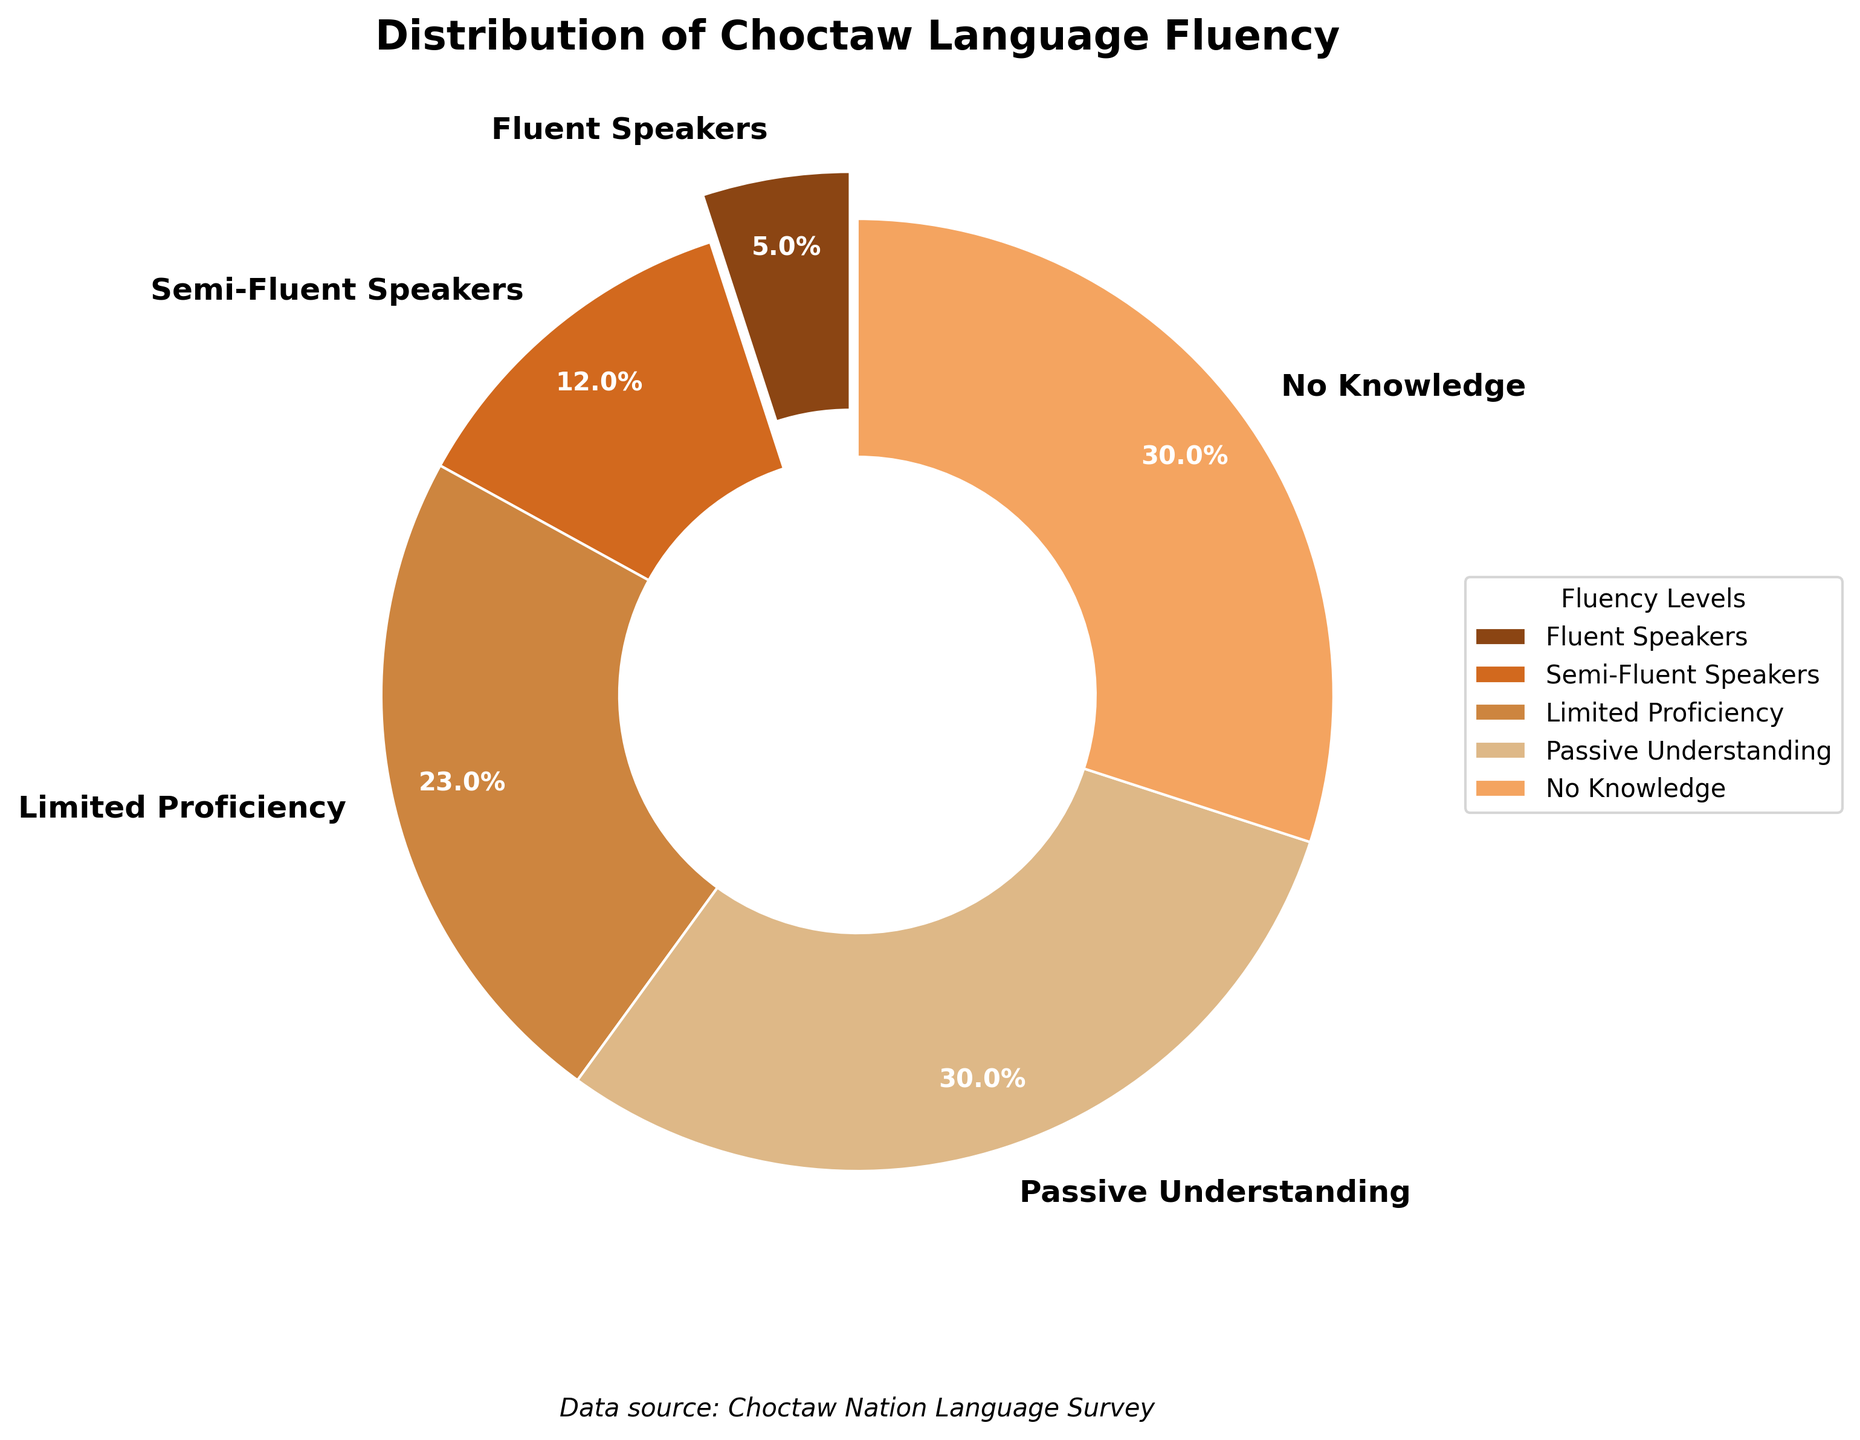What is the percentage of tribal members who are fluent speakers of the Choctaw language? The pie chart shows that the portion labeled "Fluent Speakers" has a percentage of 5% in the pie chart.
Answer: 5% Which fluency level has the highest percentage? By examining the sizes of the pie chart sections, the segments labeled "Passive Understanding" and "No Knowledge" each occupy the largest portion, both at 30%.
Answer: Passive Understanding and No Knowledge How many times more tribal members have passive understanding compared to those who are fluent speakers? The percentage of tribal members with passive understanding is 30%, and the percentage of fluent speakers is 5%. Dividing 30 by 5 gives the factor by which there are more members with passive understanding: 30 / 5 = 6.
Answer: 6 times What is the combined percentage of tribal members with limited proficiency and semi-fluent speakers? Adding the percentages of tribal members with limited proficiency (23%) and semi-fluent speakers (12%), we get 23 + 12 = 35%.
Answer: 35% Which fluency level has a greater percentage, Limited Proficiency or Semi-Fluent Speakers? By comparing the two sections, we see that Limited Proficiency (23%) is larger than Semi-Fluent Speakers (12%).
Answer: Limited Proficiency What percentage of tribal members have either no knowledge or passive understanding of the Choctaw language? Adding the percentages of tribal members with no knowledge (30%) and those with passive understanding (30%), we get 30 + 30 = 60%.
Answer: 60% What is the total percentage of tribal members who have some degree of proficiency (fluent, semi-fluent, limited proficiency) in the Choctaw language? Adding the percentages of fluent speakers (5%), semi-fluent speakers (12%), and those with limited proficiency (23%), we get 5 + 12 + 23 = 40%.
Answer: 40% Which section of the pie chart is visually the most prominent, and how can you tell? The most prominent section of the pie chart is one of the sections at 30% (either "Passive Understanding" or "No Knowledge") as they cover the largest areas of the chart.
Answer: Passive Understanding and No Knowledge (both at 30%) What is the difference in percentage between tribal members with fluent speakers and those with semi-fluent speakers? Subtracting the percentage of fluent speakers (5%) from that of semi-fluent speakers (12%), we get 12 - 5 = 7%.
Answer: 7% Is there an equal representation between the groups who have no knowledge and those who have passive understanding of the Choctaw language? Yes, both "No Knowledge" and "Passive Understanding" sections are labeled with 30%, indicating equal representation.
Answer: Yes 